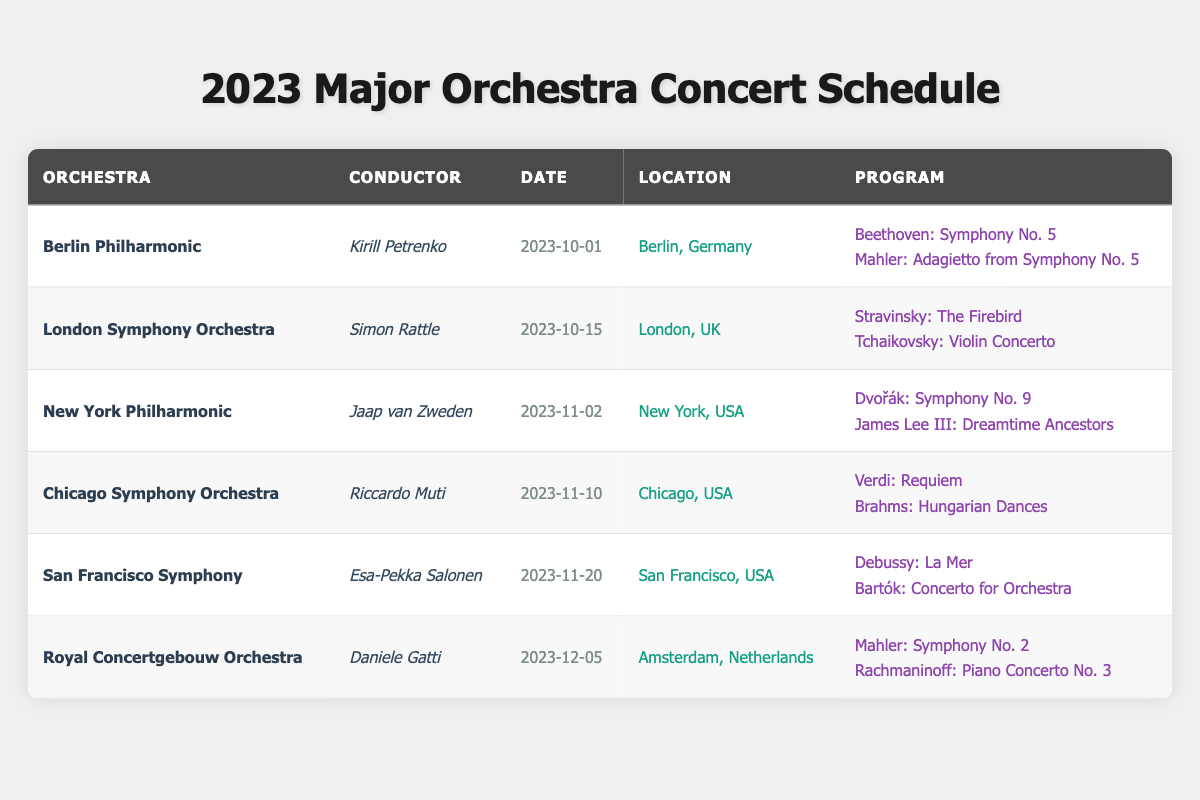What is the date of the concert by the Berlin Philharmonic? The Berlin Philharmonic concert is scheduled for 2023-10-01, as listed in the table under the date column for that orchestra.
Answer: 2023-10-01 Who is conducting the concert for the San Francisco Symphony? The conductor for the San Francisco Symphony concert is Esa-Pekka Salonen, which can be found in the conductor column for that orchestra's row.
Answer: Esa-Pekka Salonen How many concerts are scheduled in November 2023? There are three concerts scheduled in November: the New York Philharmonic on 2023-11-02, the Chicago Symphony Orchestra on 2023-11-10, and the San Francisco Symphony on 2023-11-20. Adding these together gives a total of 3 concerts in November.
Answer: 3 Is the Mahler Symphony No. 2 part of the Royal Concertgebouw Orchestra's program? Yes, the Mahler Symphony No. 2 is included in the program for the Royal Concertgebouw Orchestra, as seen in the program column for that orchestra’s row.
Answer: Yes Which location is associated with the concert on November 10, 2023? The concert on November 10, 2023, by the Chicago Symphony Orchestra takes place in Chicago, USA, as indicated in the location column for that date.
Answer: Chicago, USA What is the total number of different conductors named in the table? The table includes six different conductors: Kirill Petrenko, Simon Rattle, Jaap van Zweden, Riccardo Muti, Esa-Pekka Salonen, and Daniele Gatti. Therefore, the total count is 6.
Answer: 6 Which program features both a symphony and a piano concerto? The Royal Concertgebouw Orchestra's program features both a symphony (Mahler: Symphony No. 2) and a piano concerto (Rachmaninoff: Piano Concerto No. 3) as listed in the program column.
Answer: Royal Concertgebouw Orchestra Who is the conductor of the concert featuring "The Firebird"? The concert featuring "The Firebird" is conducted by Simon Rattle, as indicated in the program for the London Symphony Orchestra scheduled on 2023-10-15.
Answer: Simon Rattle What is the location of the New York Philharmonic concert? The New York Philharmonic concert is located in New York, USA, as detailed in the location column for that concert’s row in the table.
Answer: New York, USA 